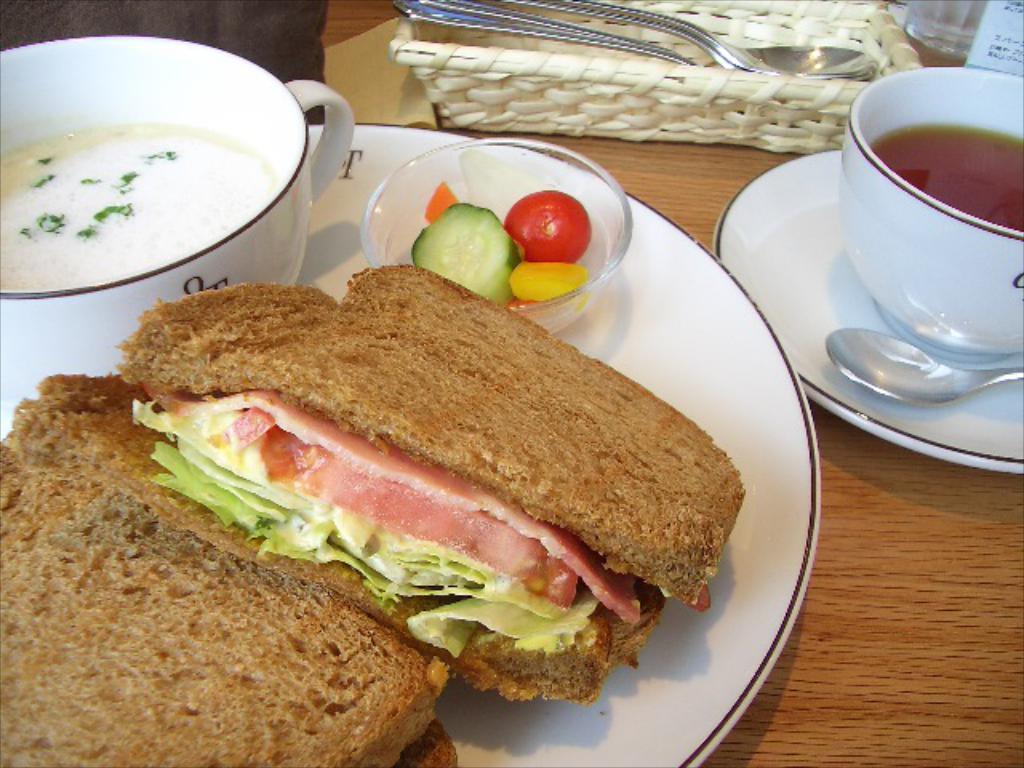Please provide a concise description of this image. In the image in the center, we can see one table. On the table, we can see plates, cups, bowls, spoons, some food items and one basket. 